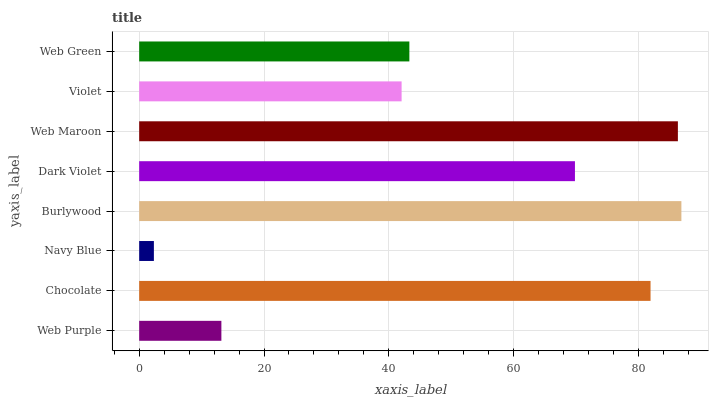Is Navy Blue the minimum?
Answer yes or no. Yes. Is Burlywood the maximum?
Answer yes or no. Yes. Is Chocolate the minimum?
Answer yes or no. No. Is Chocolate the maximum?
Answer yes or no. No. Is Chocolate greater than Web Purple?
Answer yes or no. Yes. Is Web Purple less than Chocolate?
Answer yes or no. Yes. Is Web Purple greater than Chocolate?
Answer yes or no. No. Is Chocolate less than Web Purple?
Answer yes or no. No. Is Dark Violet the high median?
Answer yes or no. Yes. Is Web Green the low median?
Answer yes or no. Yes. Is Navy Blue the high median?
Answer yes or no. No. Is Burlywood the low median?
Answer yes or no. No. 